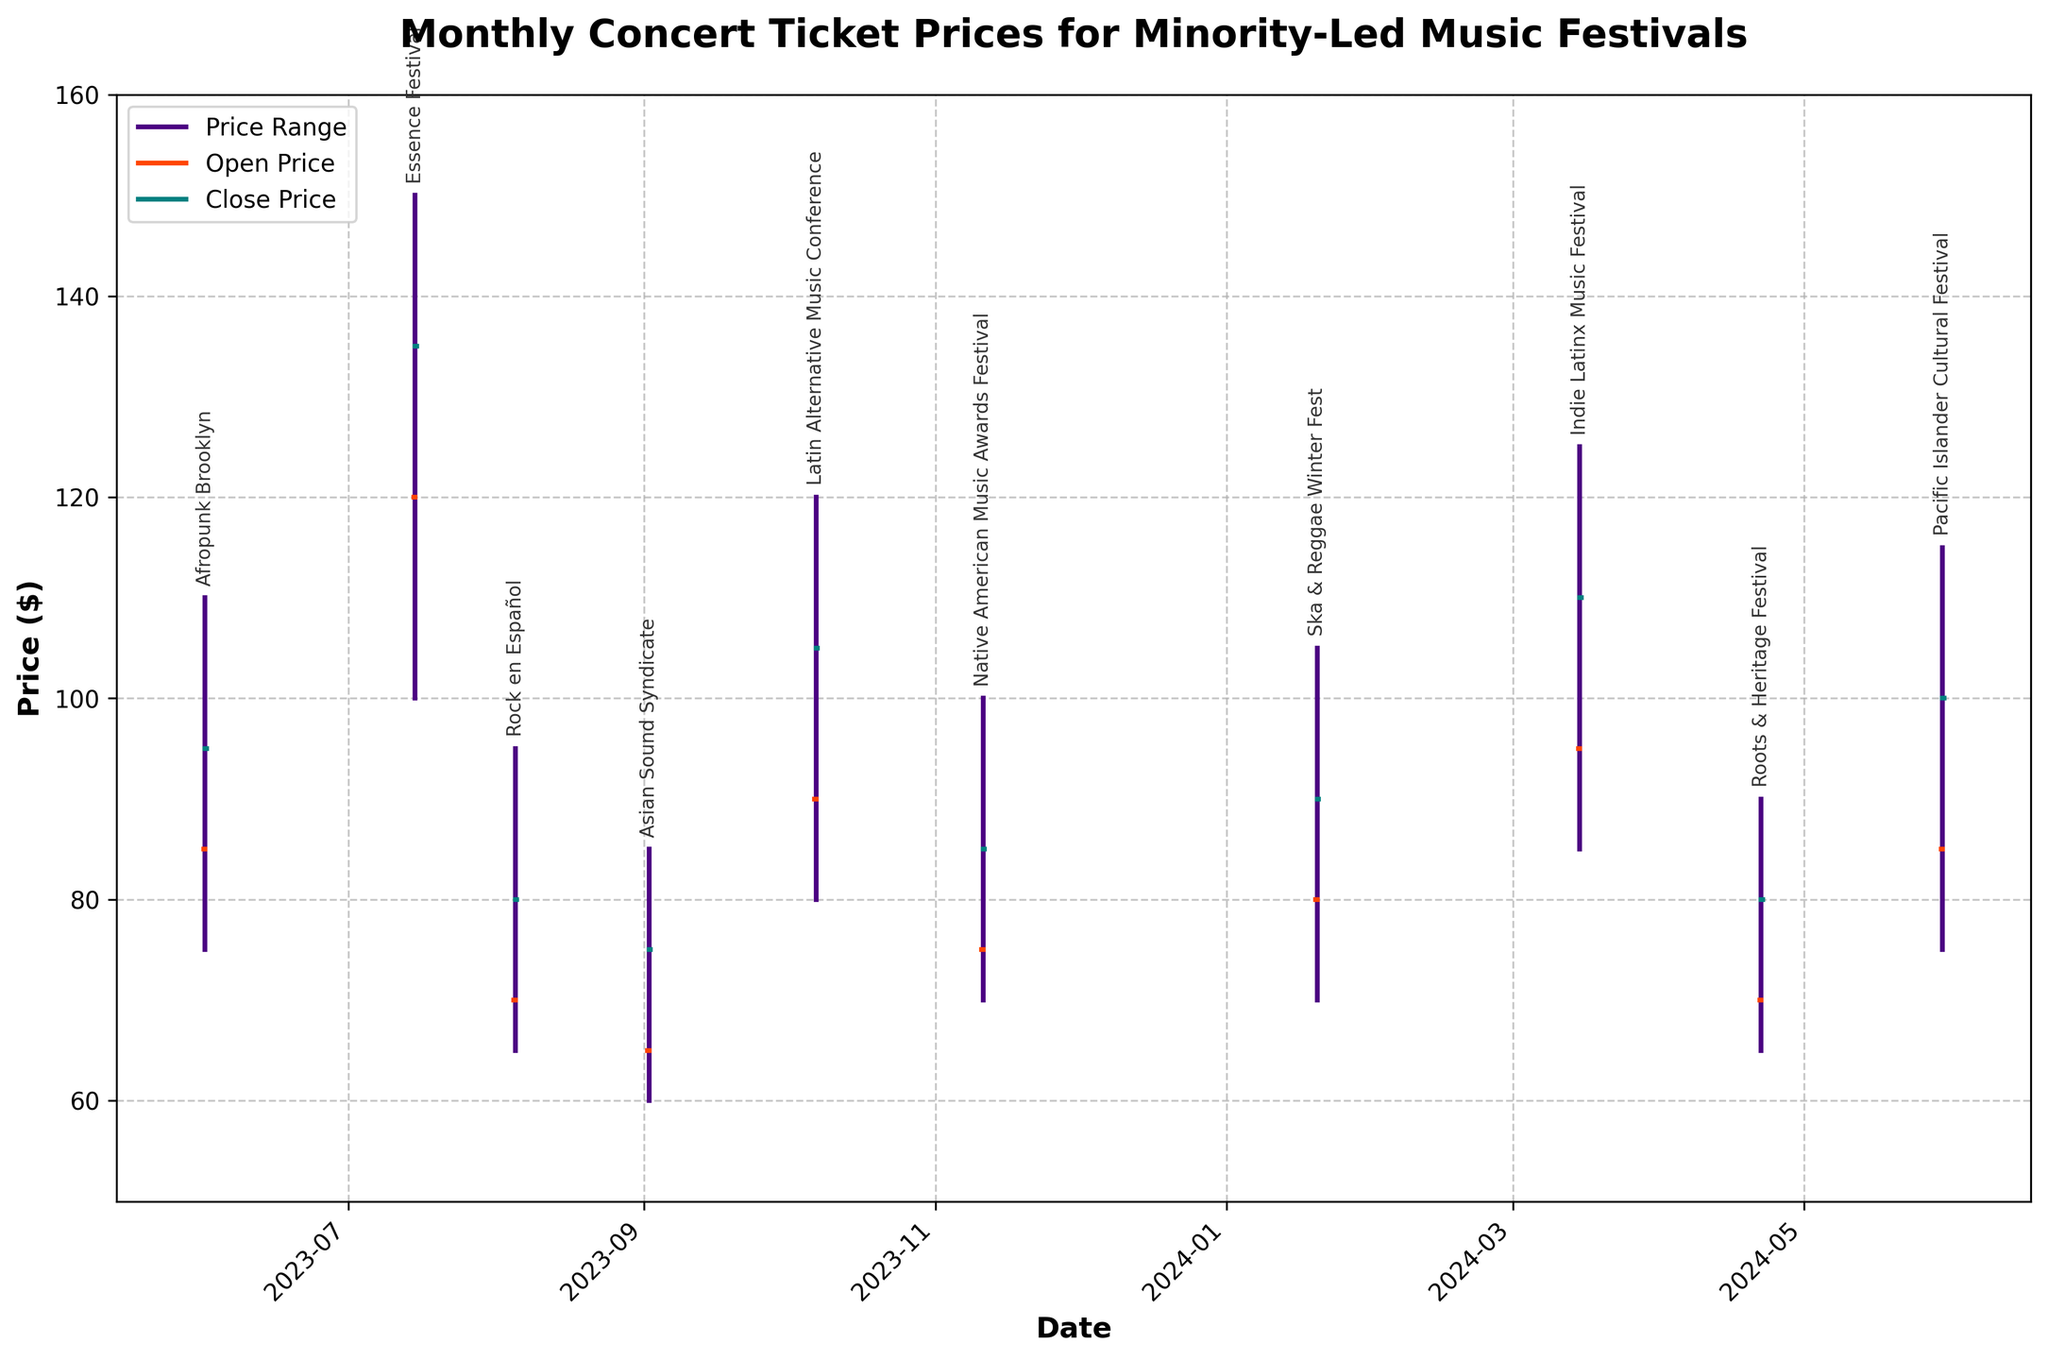What is the title of the chart? The title is the text located at the top of the chart. It provides a descriptive summary of the visual's subject matter. The title of the chart is "Monthly Concert Ticket Prices for Minority-Led Music Festivals".
Answer: Monthly Concert Ticket Prices for Minority-Led Music Festivals How many festivals are displayed in the chart? By counting the unique festival names annotated along the x-axis, we can see that there are 10 festivals listed on the chart.
Answer: 10 Which festival has the highest ticket price recorded and what is that price? By examining the highest points on the price range lines for each festival, the highest recorded ticket price is for "Essence Festival" with a price of $150.
Answer: Essence Festival, $150 Which festival has the lowest closing price and what is that price? To find this, we look at the end point of the shorter horizontal line for each festival, which represents the closing price. "Asian Sound Syndicate" has the lowest closing price at $75.
Answer: Asian Sound Syndicate, $75 What is the price range for "Afropunk Brooklyn"? The price range is represented by the vertical line which extends from the lowest to the highest price. For "Afropunk Brooklyn", the range is from $75 to $110.
Answer: $75 to $110 Which festival experienced the smallest price range and what was that range? The festival with the shortest vertical line has the smallest range. "Asian Sound Syndicate" experienced a range from $60 to $85, so the range is $25.
Answer: Asian Sound Syndicate, $25 Compare the opening and closing prices for "Native American Music Awards Festival". What is the difference? By checking the left and right horizontal ticks for the "Native American Music Awards Festival", the opening price was $75, and the closing price was $85. The difference is $85 - $75 = $10.
Answer: $10 Which two festivals had identical opening prices and what were those prices? Identical opening prices can be seen by matching the beginning of the left horizontal ticks. "Pacific Islander Cultural Festival" and "Afropunk Brooklyn" both opened at $85.
Answer: Pacific Islander Cultural Festival, Afropunk Brooklyn; $85 What is the average closing price for all the festivals? By adding all the closing prices and dividing by the number of festivals: (95 + 135 + 80 + 75 + 105 + 85 + 90 + 110 + 80 + 100)/10 = 955/10 = 95.5.
Answer: $95.5 What was the highest recorded price in the month of March, and for which festival was it recorded? By identifying the price range for each festival, the month of March features "Indie Latinx Music Festival" with a highest price of $125.
Answer: Indie Latinx Music Festival, $125 